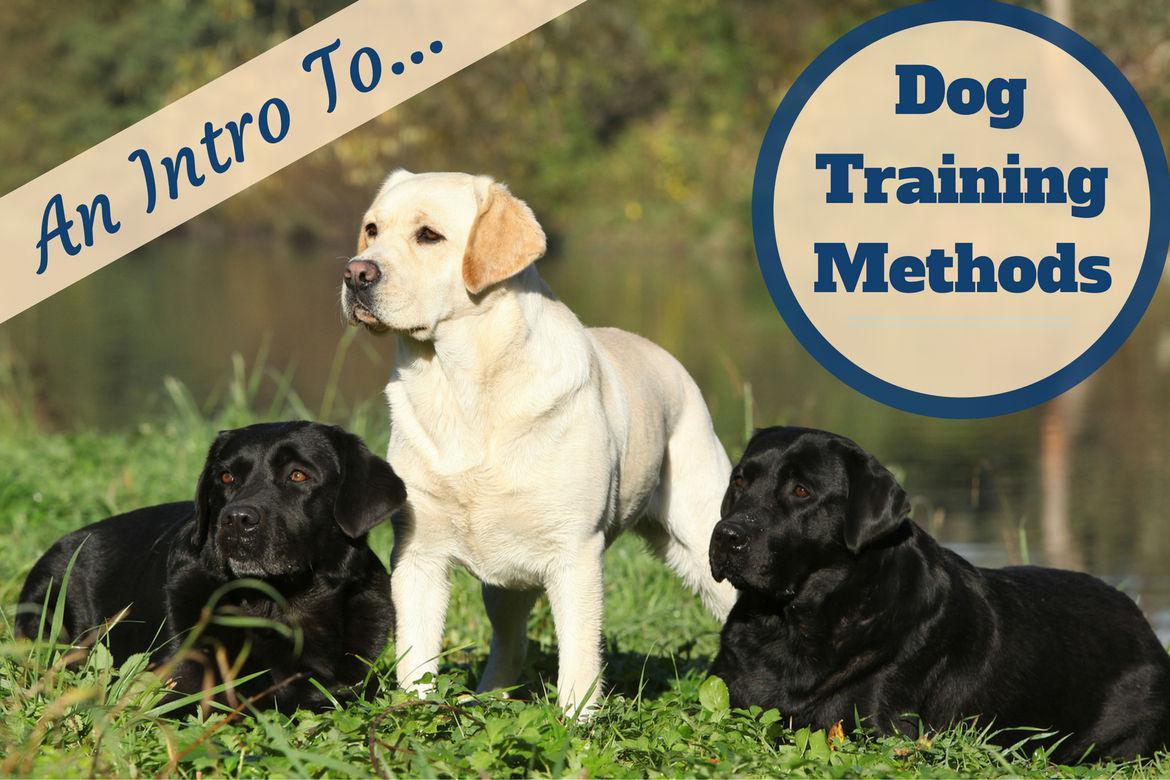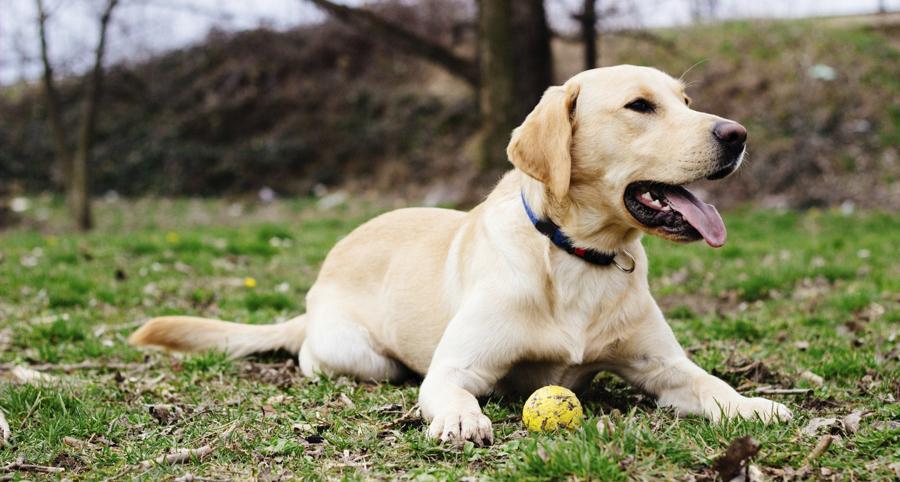The first image is the image on the left, the second image is the image on the right. Evaluate the accuracy of this statement regarding the images: "There is at least one human touching a dog.". Is it true? Answer yes or no. No. The first image is the image on the left, the second image is the image on the right. For the images shown, is this caption "One image shows a lone dog facing the right with his mouth open." true? Answer yes or no. Yes. 